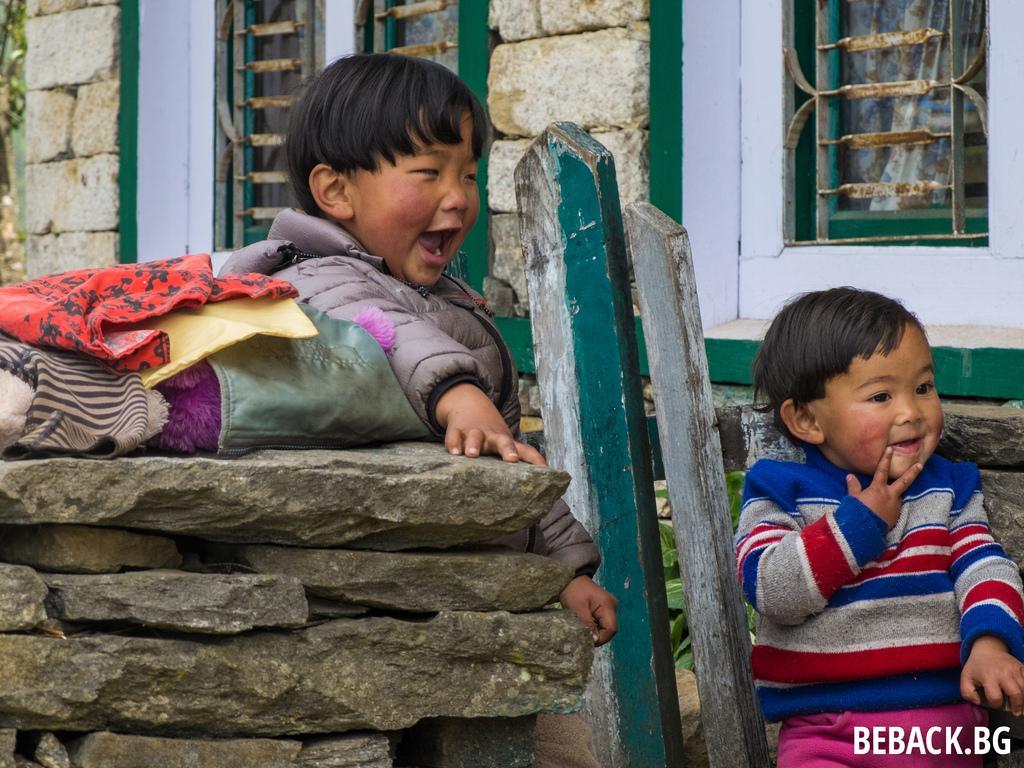Could you give a brief overview of what you see in this image? In this image I can see two children and I can see one of them is wearing a jacket. In the background I can see two windows and on the left side of this image I can see few clothes on the stones. On the right bottom side of this image I can see a watermark. I can also see a planet behind the wooden poles. 